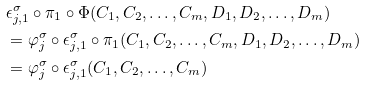<formula> <loc_0><loc_0><loc_500><loc_500>& \epsilon _ { j , 1 } ^ { \sigma } \circ \pi _ { 1 } \circ \Phi ( C _ { 1 } , C _ { 2 } , \dots , C _ { m } , D _ { 1 } , D _ { 2 } , \dots , D _ { m } ) \\ & = \varphi ^ { \sigma } _ { j } \circ \epsilon _ { j , 1 } ^ { \sigma } \circ \pi _ { 1 } ( C _ { 1 } , C _ { 2 } , \dots , C _ { m } , D _ { 1 } , D _ { 2 } , \dots , D _ { m } ) \\ & = \varphi ^ { \sigma } _ { j } \circ \epsilon _ { j , 1 } ^ { \sigma } ( C _ { 1 } , C _ { 2 } , \dots , C _ { m } )</formula> 